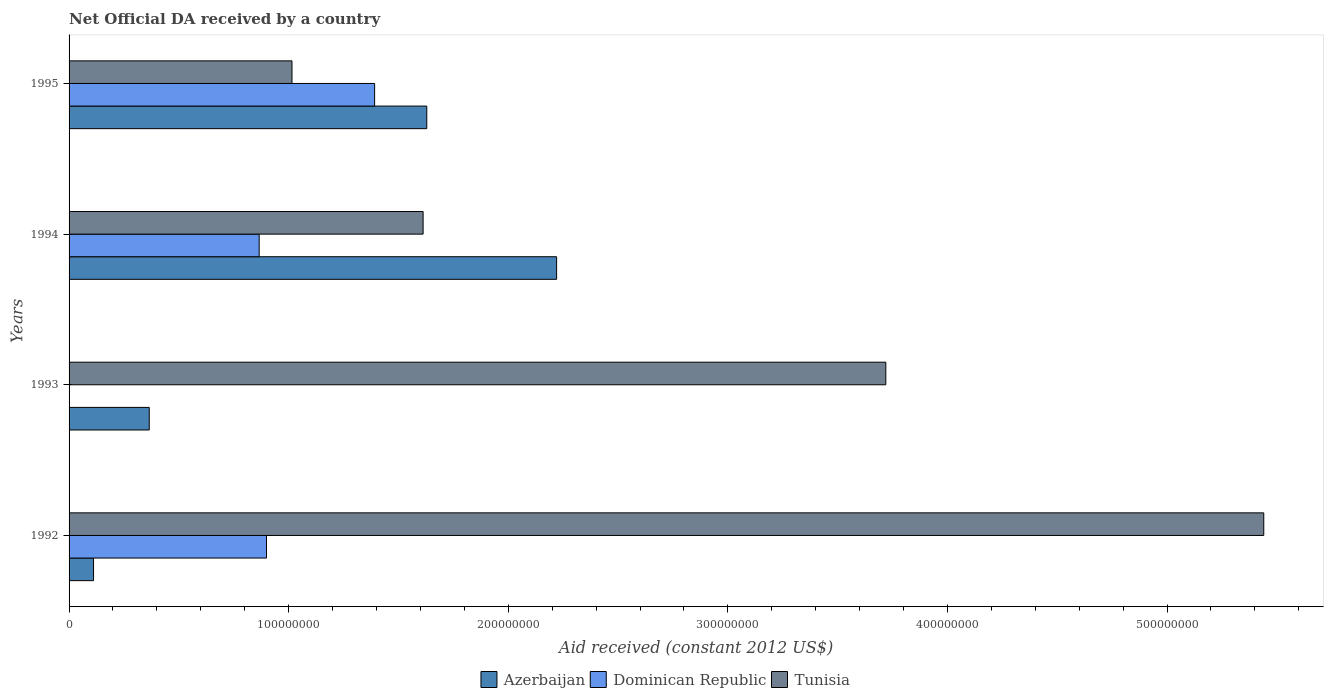Are the number of bars per tick equal to the number of legend labels?
Your response must be concise. No. Are the number of bars on each tick of the Y-axis equal?
Your answer should be very brief. No. How many bars are there on the 3rd tick from the bottom?
Keep it short and to the point. 3. What is the label of the 1st group of bars from the top?
Ensure brevity in your answer.  1995. In how many cases, is the number of bars for a given year not equal to the number of legend labels?
Your response must be concise. 1. What is the net official development assistance aid received in Dominican Republic in 1993?
Keep it short and to the point. 0. Across all years, what is the maximum net official development assistance aid received in Tunisia?
Offer a very short reply. 5.44e+08. Across all years, what is the minimum net official development assistance aid received in Tunisia?
Provide a succinct answer. 1.02e+08. What is the total net official development assistance aid received in Tunisia in the graph?
Your answer should be very brief. 1.18e+09. What is the difference between the net official development assistance aid received in Azerbaijan in 1994 and that in 1995?
Offer a very short reply. 5.91e+07. What is the difference between the net official development assistance aid received in Tunisia in 1993 and the net official development assistance aid received in Dominican Republic in 1995?
Offer a terse response. 2.33e+08. What is the average net official development assistance aid received in Azerbaijan per year?
Keep it short and to the point. 1.08e+08. In the year 1993, what is the difference between the net official development assistance aid received in Azerbaijan and net official development assistance aid received in Tunisia?
Keep it short and to the point. -3.35e+08. In how many years, is the net official development assistance aid received in Azerbaijan greater than 400000000 US$?
Provide a short and direct response. 0. What is the ratio of the net official development assistance aid received in Azerbaijan in 1993 to that in 1994?
Make the answer very short. 0.16. Is the difference between the net official development assistance aid received in Azerbaijan in 1993 and 1994 greater than the difference between the net official development assistance aid received in Tunisia in 1993 and 1994?
Your response must be concise. No. What is the difference between the highest and the second highest net official development assistance aid received in Azerbaijan?
Make the answer very short. 5.91e+07. What is the difference between the highest and the lowest net official development assistance aid received in Tunisia?
Your response must be concise. 4.43e+08. In how many years, is the net official development assistance aid received in Tunisia greater than the average net official development assistance aid received in Tunisia taken over all years?
Give a very brief answer. 2. Is the sum of the net official development assistance aid received in Azerbaijan in 1992 and 1994 greater than the maximum net official development assistance aid received in Tunisia across all years?
Give a very brief answer. No. Is it the case that in every year, the sum of the net official development assistance aid received in Azerbaijan and net official development assistance aid received in Dominican Republic is greater than the net official development assistance aid received in Tunisia?
Your response must be concise. No. How many bars are there?
Ensure brevity in your answer.  11. Does the graph contain any zero values?
Offer a terse response. Yes. Where does the legend appear in the graph?
Offer a very short reply. Bottom center. What is the title of the graph?
Provide a short and direct response. Net Official DA received by a country. Does "Turkey" appear as one of the legend labels in the graph?
Your answer should be very brief. No. What is the label or title of the X-axis?
Your response must be concise. Aid received (constant 2012 US$). What is the Aid received (constant 2012 US$) in Azerbaijan in 1992?
Your answer should be compact. 1.11e+07. What is the Aid received (constant 2012 US$) in Dominican Republic in 1992?
Your response must be concise. 8.99e+07. What is the Aid received (constant 2012 US$) in Tunisia in 1992?
Ensure brevity in your answer.  5.44e+08. What is the Aid received (constant 2012 US$) in Azerbaijan in 1993?
Provide a succinct answer. 3.65e+07. What is the Aid received (constant 2012 US$) in Dominican Republic in 1993?
Ensure brevity in your answer.  0. What is the Aid received (constant 2012 US$) in Tunisia in 1993?
Keep it short and to the point. 3.72e+08. What is the Aid received (constant 2012 US$) in Azerbaijan in 1994?
Your response must be concise. 2.22e+08. What is the Aid received (constant 2012 US$) in Dominican Republic in 1994?
Ensure brevity in your answer.  8.66e+07. What is the Aid received (constant 2012 US$) of Tunisia in 1994?
Keep it short and to the point. 1.61e+08. What is the Aid received (constant 2012 US$) in Azerbaijan in 1995?
Provide a succinct answer. 1.63e+08. What is the Aid received (constant 2012 US$) of Dominican Republic in 1995?
Provide a short and direct response. 1.39e+08. What is the Aid received (constant 2012 US$) in Tunisia in 1995?
Ensure brevity in your answer.  1.02e+08. Across all years, what is the maximum Aid received (constant 2012 US$) in Azerbaijan?
Your answer should be compact. 2.22e+08. Across all years, what is the maximum Aid received (constant 2012 US$) in Dominican Republic?
Give a very brief answer. 1.39e+08. Across all years, what is the maximum Aid received (constant 2012 US$) in Tunisia?
Your answer should be very brief. 5.44e+08. Across all years, what is the minimum Aid received (constant 2012 US$) in Azerbaijan?
Ensure brevity in your answer.  1.11e+07. Across all years, what is the minimum Aid received (constant 2012 US$) of Dominican Republic?
Give a very brief answer. 0. Across all years, what is the minimum Aid received (constant 2012 US$) in Tunisia?
Make the answer very short. 1.02e+08. What is the total Aid received (constant 2012 US$) of Azerbaijan in the graph?
Your response must be concise. 4.33e+08. What is the total Aid received (constant 2012 US$) in Dominican Republic in the graph?
Provide a short and direct response. 3.16e+08. What is the total Aid received (constant 2012 US$) in Tunisia in the graph?
Offer a terse response. 1.18e+09. What is the difference between the Aid received (constant 2012 US$) in Azerbaijan in 1992 and that in 1993?
Offer a very short reply. -2.54e+07. What is the difference between the Aid received (constant 2012 US$) of Tunisia in 1992 and that in 1993?
Offer a terse response. 1.72e+08. What is the difference between the Aid received (constant 2012 US$) in Azerbaijan in 1992 and that in 1994?
Offer a terse response. -2.11e+08. What is the difference between the Aid received (constant 2012 US$) in Dominican Republic in 1992 and that in 1994?
Keep it short and to the point. 3.34e+06. What is the difference between the Aid received (constant 2012 US$) of Tunisia in 1992 and that in 1994?
Your answer should be compact. 3.83e+08. What is the difference between the Aid received (constant 2012 US$) in Azerbaijan in 1992 and that in 1995?
Ensure brevity in your answer.  -1.52e+08. What is the difference between the Aid received (constant 2012 US$) of Dominican Republic in 1992 and that in 1995?
Make the answer very short. -4.92e+07. What is the difference between the Aid received (constant 2012 US$) in Tunisia in 1992 and that in 1995?
Your answer should be compact. 4.43e+08. What is the difference between the Aid received (constant 2012 US$) of Azerbaijan in 1993 and that in 1994?
Provide a short and direct response. -1.86e+08. What is the difference between the Aid received (constant 2012 US$) in Tunisia in 1993 and that in 1994?
Offer a very short reply. 2.11e+08. What is the difference between the Aid received (constant 2012 US$) in Azerbaijan in 1993 and that in 1995?
Offer a very short reply. -1.26e+08. What is the difference between the Aid received (constant 2012 US$) in Tunisia in 1993 and that in 1995?
Make the answer very short. 2.70e+08. What is the difference between the Aid received (constant 2012 US$) in Azerbaijan in 1994 and that in 1995?
Ensure brevity in your answer.  5.91e+07. What is the difference between the Aid received (constant 2012 US$) in Dominican Republic in 1994 and that in 1995?
Provide a succinct answer. -5.26e+07. What is the difference between the Aid received (constant 2012 US$) of Tunisia in 1994 and that in 1995?
Offer a very short reply. 5.97e+07. What is the difference between the Aid received (constant 2012 US$) in Azerbaijan in 1992 and the Aid received (constant 2012 US$) in Tunisia in 1993?
Offer a terse response. -3.61e+08. What is the difference between the Aid received (constant 2012 US$) of Dominican Republic in 1992 and the Aid received (constant 2012 US$) of Tunisia in 1993?
Offer a terse response. -2.82e+08. What is the difference between the Aid received (constant 2012 US$) in Azerbaijan in 1992 and the Aid received (constant 2012 US$) in Dominican Republic in 1994?
Ensure brevity in your answer.  -7.54e+07. What is the difference between the Aid received (constant 2012 US$) in Azerbaijan in 1992 and the Aid received (constant 2012 US$) in Tunisia in 1994?
Make the answer very short. -1.50e+08. What is the difference between the Aid received (constant 2012 US$) in Dominican Republic in 1992 and the Aid received (constant 2012 US$) in Tunisia in 1994?
Provide a short and direct response. -7.13e+07. What is the difference between the Aid received (constant 2012 US$) in Azerbaijan in 1992 and the Aid received (constant 2012 US$) in Dominican Republic in 1995?
Provide a short and direct response. -1.28e+08. What is the difference between the Aid received (constant 2012 US$) in Azerbaijan in 1992 and the Aid received (constant 2012 US$) in Tunisia in 1995?
Keep it short and to the point. -9.04e+07. What is the difference between the Aid received (constant 2012 US$) of Dominican Republic in 1992 and the Aid received (constant 2012 US$) of Tunisia in 1995?
Provide a short and direct response. -1.16e+07. What is the difference between the Aid received (constant 2012 US$) in Azerbaijan in 1993 and the Aid received (constant 2012 US$) in Dominican Republic in 1994?
Your answer should be very brief. -5.01e+07. What is the difference between the Aid received (constant 2012 US$) of Azerbaijan in 1993 and the Aid received (constant 2012 US$) of Tunisia in 1994?
Your answer should be very brief. -1.25e+08. What is the difference between the Aid received (constant 2012 US$) of Azerbaijan in 1993 and the Aid received (constant 2012 US$) of Dominican Republic in 1995?
Your answer should be compact. -1.03e+08. What is the difference between the Aid received (constant 2012 US$) in Azerbaijan in 1993 and the Aid received (constant 2012 US$) in Tunisia in 1995?
Provide a short and direct response. -6.50e+07. What is the difference between the Aid received (constant 2012 US$) of Azerbaijan in 1994 and the Aid received (constant 2012 US$) of Dominican Republic in 1995?
Keep it short and to the point. 8.29e+07. What is the difference between the Aid received (constant 2012 US$) of Azerbaijan in 1994 and the Aid received (constant 2012 US$) of Tunisia in 1995?
Offer a very short reply. 1.20e+08. What is the difference between the Aid received (constant 2012 US$) of Dominican Republic in 1994 and the Aid received (constant 2012 US$) of Tunisia in 1995?
Your answer should be compact. -1.49e+07. What is the average Aid received (constant 2012 US$) in Azerbaijan per year?
Make the answer very short. 1.08e+08. What is the average Aid received (constant 2012 US$) in Dominican Republic per year?
Provide a short and direct response. 7.89e+07. What is the average Aid received (constant 2012 US$) of Tunisia per year?
Your response must be concise. 2.95e+08. In the year 1992, what is the difference between the Aid received (constant 2012 US$) of Azerbaijan and Aid received (constant 2012 US$) of Dominican Republic?
Your answer should be compact. -7.88e+07. In the year 1992, what is the difference between the Aid received (constant 2012 US$) in Azerbaijan and Aid received (constant 2012 US$) in Tunisia?
Your answer should be compact. -5.33e+08. In the year 1992, what is the difference between the Aid received (constant 2012 US$) in Dominican Republic and Aid received (constant 2012 US$) in Tunisia?
Make the answer very short. -4.54e+08. In the year 1993, what is the difference between the Aid received (constant 2012 US$) in Azerbaijan and Aid received (constant 2012 US$) in Tunisia?
Keep it short and to the point. -3.35e+08. In the year 1994, what is the difference between the Aid received (constant 2012 US$) in Azerbaijan and Aid received (constant 2012 US$) in Dominican Republic?
Your answer should be compact. 1.35e+08. In the year 1994, what is the difference between the Aid received (constant 2012 US$) of Azerbaijan and Aid received (constant 2012 US$) of Tunisia?
Your response must be concise. 6.08e+07. In the year 1994, what is the difference between the Aid received (constant 2012 US$) of Dominican Republic and Aid received (constant 2012 US$) of Tunisia?
Give a very brief answer. -7.46e+07. In the year 1995, what is the difference between the Aid received (constant 2012 US$) of Azerbaijan and Aid received (constant 2012 US$) of Dominican Republic?
Offer a very short reply. 2.38e+07. In the year 1995, what is the difference between the Aid received (constant 2012 US$) of Azerbaijan and Aid received (constant 2012 US$) of Tunisia?
Your response must be concise. 6.14e+07. In the year 1995, what is the difference between the Aid received (constant 2012 US$) in Dominican Republic and Aid received (constant 2012 US$) in Tunisia?
Your answer should be compact. 3.76e+07. What is the ratio of the Aid received (constant 2012 US$) in Azerbaijan in 1992 to that in 1993?
Your answer should be very brief. 0.31. What is the ratio of the Aid received (constant 2012 US$) of Tunisia in 1992 to that in 1993?
Provide a succinct answer. 1.46. What is the ratio of the Aid received (constant 2012 US$) in Azerbaijan in 1992 to that in 1994?
Provide a short and direct response. 0.05. What is the ratio of the Aid received (constant 2012 US$) in Dominican Republic in 1992 to that in 1994?
Your response must be concise. 1.04. What is the ratio of the Aid received (constant 2012 US$) of Tunisia in 1992 to that in 1994?
Your answer should be very brief. 3.37. What is the ratio of the Aid received (constant 2012 US$) in Azerbaijan in 1992 to that in 1995?
Your answer should be compact. 0.07. What is the ratio of the Aid received (constant 2012 US$) of Dominican Republic in 1992 to that in 1995?
Your response must be concise. 0.65. What is the ratio of the Aid received (constant 2012 US$) in Tunisia in 1992 to that in 1995?
Your answer should be very brief. 5.36. What is the ratio of the Aid received (constant 2012 US$) of Azerbaijan in 1993 to that in 1994?
Your response must be concise. 0.16. What is the ratio of the Aid received (constant 2012 US$) in Tunisia in 1993 to that in 1994?
Offer a very short reply. 2.31. What is the ratio of the Aid received (constant 2012 US$) of Azerbaijan in 1993 to that in 1995?
Offer a very short reply. 0.22. What is the ratio of the Aid received (constant 2012 US$) of Tunisia in 1993 to that in 1995?
Provide a succinct answer. 3.66. What is the ratio of the Aid received (constant 2012 US$) of Azerbaijan in 1994 to that in 1995?
Your answer should be very brief. 1.36. What is the ratio of the Aid received (constant 2012 US$) in Dominican Republic in 1994 to that in 1995?
Provide a short and direct response. 0.62. What is the ratio of the Aid received (constant 2012 US$) of Tunisia in 1994 to that in 1995?
Make the answer very short. 1.59. What is the difference between the highest and the second highest Aid received (constant 2012 US$) in Azerbaijan?
Ensure brevity in your answer.  5.91e+07. What is the difference between the highest and the second highest Aid received (constant 2012 US$) in Dominican Republic?
Your answer should be very brief. 4.92e+07. What is the difference between the highest and the second highest Aid received (constant 2012 US$) in Tunisia?
Ensure brevity in your answer.  1.72e+08. What is the difference between the highest and the lowest Aid received (constant 2012 US$) in Azerbaijan?
Offer a very short reply. 2.11e+08. What is the difference between the highest and the lowest Aid received (constant 2012 US$) of Dominican Republic?
Your answer should be compact. 1.39e+08. What is the difference between the highest and the lowest Aid received (constant 2012 US$) of Tunisia?
Give a very brief answer. 4.43e+08. 